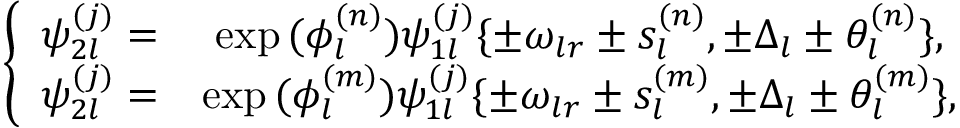Convert formula to latex. <formula><loc_0><loc_0><loc_500><loc_500>\begin{array} { r } { \left \{ \begin{array} { c c c } { \psi _ { 2 l } ^ { ( j ) } = } & { \exp { ( \phi _ { l } ^ { ( n ) } ) } \psi _ { 1 l } ^ { ( j ) } \{ \pm \omega _ { l r } \pm s _ { l } ^ { ( n ) } , \pm \Delta _ { l } \pm \theta _ { l } ^ { ( n ) } \} , } \\ { \psi _ { 2 l } ^ { ( j ) } = } & { \exp { ( \phi _ { l } ^ { ( m ) } ) } \psi _ { 1 l } ^ { ( j ) } \{ \pm \omega _ { l r } \pm s _ { l } ^ { ( m ) } , \pm \Delta _ { l } \pm \theta _ { l } ^ { ( m ) } \} , } \end{array} } \end{array}</formula> 